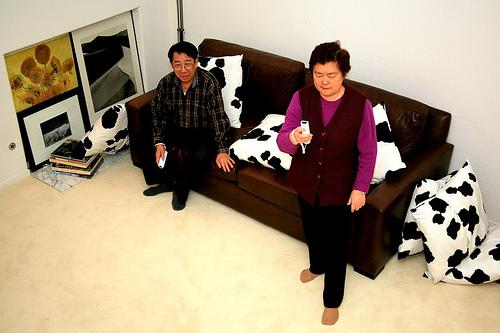Question: where was this picture taken?
Choices:
A. Dining room.
B. Bathroom.
C. A living room.
D. Kitchen.
Answer with the letter. Answer: C Question: what pattern are the pillows?
Choices:
A. Stripes.
B. Solid.
C. Floral.
D. Cow print.
Answer with the letter. Answer: D Question: who is standing?
Choices:
A. The man.
B. The girl.
C. The boy.
D. The woman.
Answer with the letter. Answer: D 